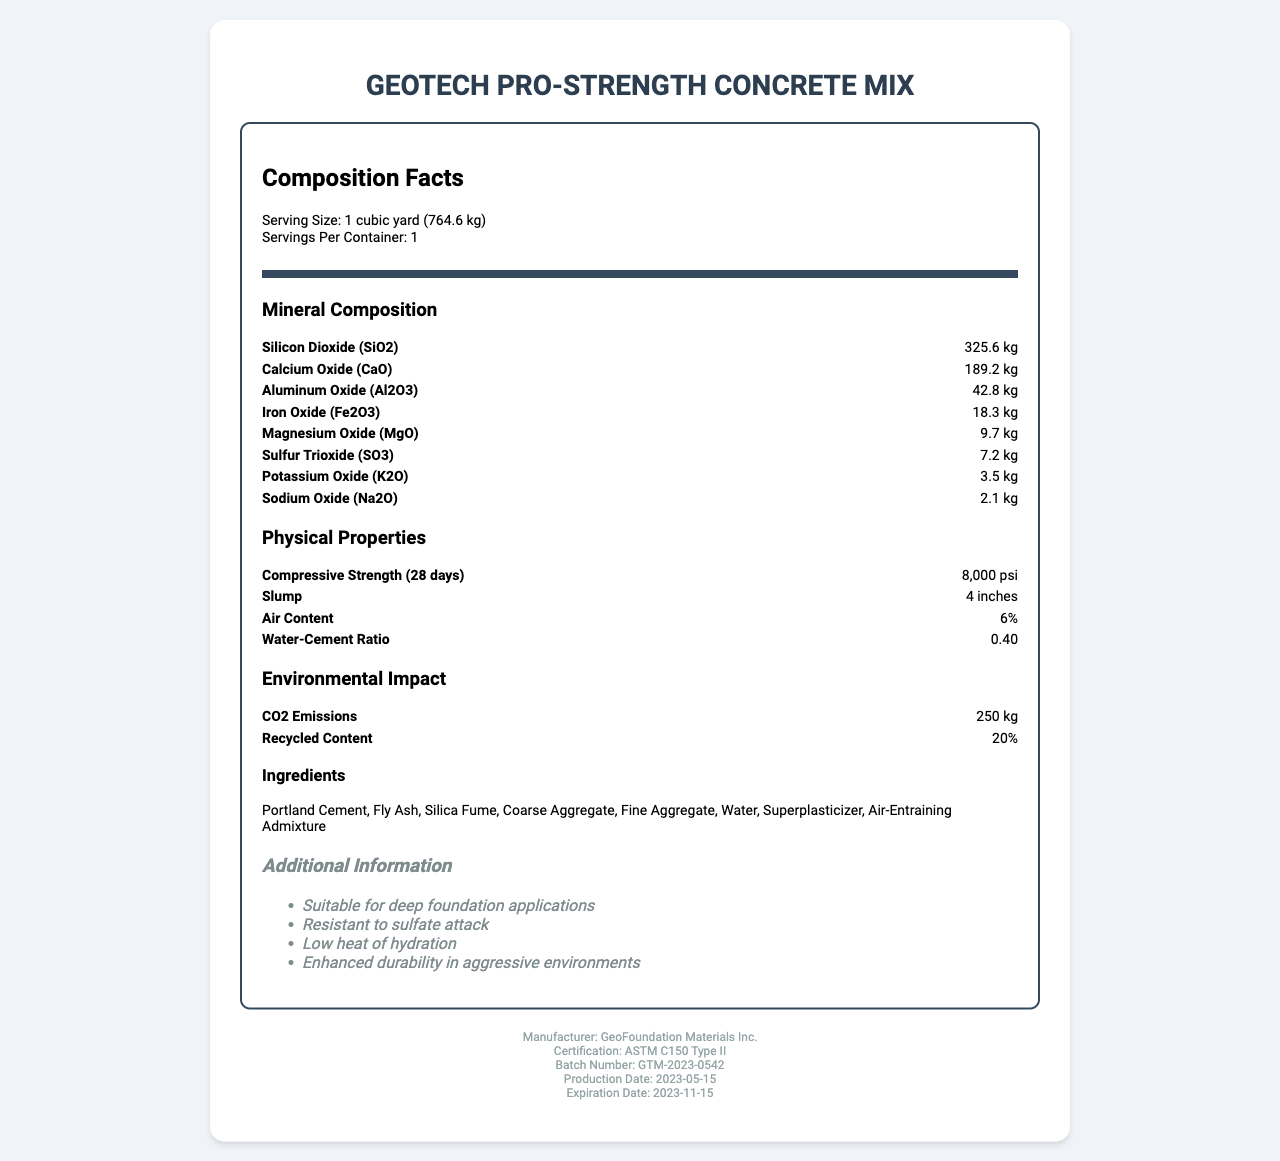what is the product name? The product name is displayed at the top of the document.
Answer: GeoTech Pro-Strength Concrete Mix what is the serving size per container? The serving size per container is mentioned under the Composition Facts section.
Answer: 1 cubic yard (764.6 kg) how much Silicon Dioxide (SiO2) is present in the mix? The amount of Silicon Dioxide (SiO2) is listed in the Mineral Composition section as 325.6 kg.
Answer: 325.6 kg what is the water-cement ratio of this mix? The water-cement ratio is listed in the Physical Properties section as 0.40.
Answer: 0.40 which ingredient helps in improving workability without increasing water content? Superplasticizer is known to improve the workability of concrete without increasing the water content.
Answer: Superplasticizer what is the compressive strength of the concrete after 28 days? a) 4,000 psi b) 6,000 psi c) 8,000 psi The compressive strength after 28 days is mentioned in the Physical Properties section as 8,000 psi.
Answer: c) 8,000 psi which of the following is an ingredient NOT listed in the ingredients of the concrete mix? A. Portland Cement B. Silica Fume C. Gypsum D. Coarse Aggregate Gypsum is not listed among the ingredients; the listed ingredients are Portland Cement, Fly Ash, Silica Fume, Coarse Aggregate, Fine Aggregate, Water, Superplasticizer, and Air-Entraining Admixture.
Answer: C. Gypsum is the concrete mix resistant to sulfate attack? The additional information section mentions that the concrete mix is resistant to sulfate attack.
Answer: Yes what is the total amount of Calcium Oxide (CaO) in the mix? The Mineral Composition section lists 189.2 kg of Calcium Oxide (CaO).
Answer: 189.2 kg how much recycled content does the concrete mix contain? The Environmental Impact section mentions that the mix contains 20% recycled content.
Answer: 20% describe the main purpose and content of the document. The document serves as a comprehensive overview of the GeoTech Pro-Strength Concrete Mix, outlining various details such as its composition, physical attributes, environmental impact, and additional beneficial properties for users, to aid in making informed decisions about its application in construction projects.
Answer: The document provides detailed information on the GeoTech Pro-Strength Concrete Mix, including its serving size, mineral composition, physical properties, environmental impact, ingredients, additional information, manufacturer details, certification, batch number, and production and expiration dates. when will the batch GTM-2023-0542 expire? The expiration date mentioned in the footer of the document is 2023-11-15.
Answer: 2023-11-15 how does the concrete mix behave in aggressive environments? The additional information section mentions that the concrete mix has enhanced durability in aggressive environments.
Answer: Enhanced durability how much CO2 emissions are generated per cubic yard of this mix? The Environmental Impact section lists CO2 emissions as 250 kg per cubic yard of the mix.
Answer: 250 kg how much Aluminum Oxide (Al2O3) does the concrete mix contain? The Mineral Composition section lists 42.8 kg of Aluminum Oxide (Al2O3).
Answer: 42.8 kg which mineral oxide is present in the smallest amount? A. Sodium Oxide (Na2O) B. Magnesium Oxide (MgO) C. Potassium Oxide (K2O) D. Iron Oxide (Fe2O3) The Mineral Composition section shows Sodium Oxide (Na2O) at 2.1 kg, which is the smallest amount compared to the other listed oxides.
Answer: A. Sodium Oxide (Na2O) what is the production date for the batch GTM-2023-0542? The production date mentioned in the footer of the document for the batch GTM-2023-0542 is 2023-05-15.
Answer: 2023-05-15 is the certification obtained by the concrete mix ASTM C150 Type I? The certification mentioned in the footer is ASTM C150 Type II, not Type I.
Answer: No how much Magnesium Oxide (MgO) does the concrete mix contain? The Mineral Composition section lists 9.7 kg of Magnesium Oxide (MgO).
Answer: 9.7 kg what is the percentage of air content in the mix? The Physical Properties section lists the air content as 6%.
Answer: 6% which ingredient acts as an air-entraining admixture? The ingredient list includes Air-Entraining Admixture as one of the components.
Answer: Air-Entraining Admixture which certification standard does the concrete mix comply with? The footer of the document mentions that the mix complies with the ASTM C150 Type II standard.
Answer: ASTM C150 Type II how does the document describe the heat of hydration for this mix? The additional information section mentions that the mix has a low heat of hydration.
Answer: Low heat of hydration what is the exact amount of Sulfur Trioxide (SO3) in the concrete mix? The Mineral Composition section lists 7.2 kg of Sulfur Trioxide (SO3).
Answer: 7.2 kg what is the batch number of the GeoTech Pro-Strength Concrete Mix? The batch number mentioned in the footer of the document is GTM-2023-0542.
Answer: GTM-2023-0542 how does the mix’s CO2 emission compare to other mixes in the industry? The document does not provide data on CO2 emissions of other mixes, so a comparison cannot be made.
Answer: Not enough information 